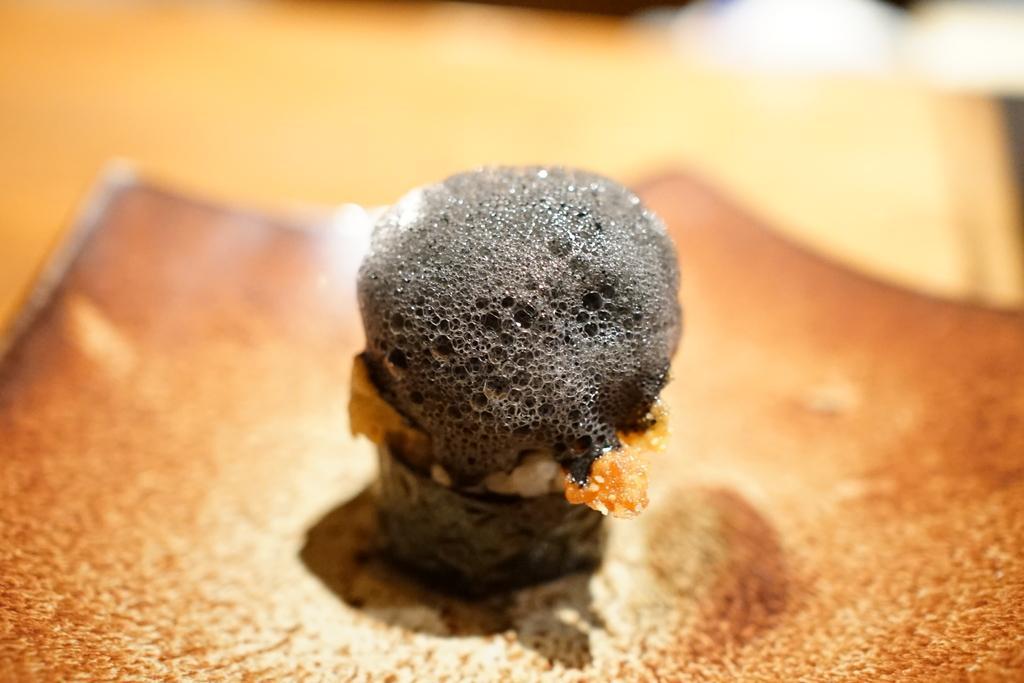Can you describe this image briefly? In this picture, it seems like a dessert in the foreground area of the image and the background is blur. 